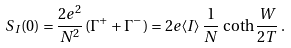<formula> <loc_0><loc_0><loc_500><loc_500>S _ { I } ( 0 ) = \frac { 2 e ^ { 2 } } { N ^ { 2 } } \, ( \Gamma ^ { + } + \Gamma ^ { - } ) = 2 e \langle I \rangle \, \frac { 1 } { N } \, \coth \frac { W } { 2 T } \, .</formula> 